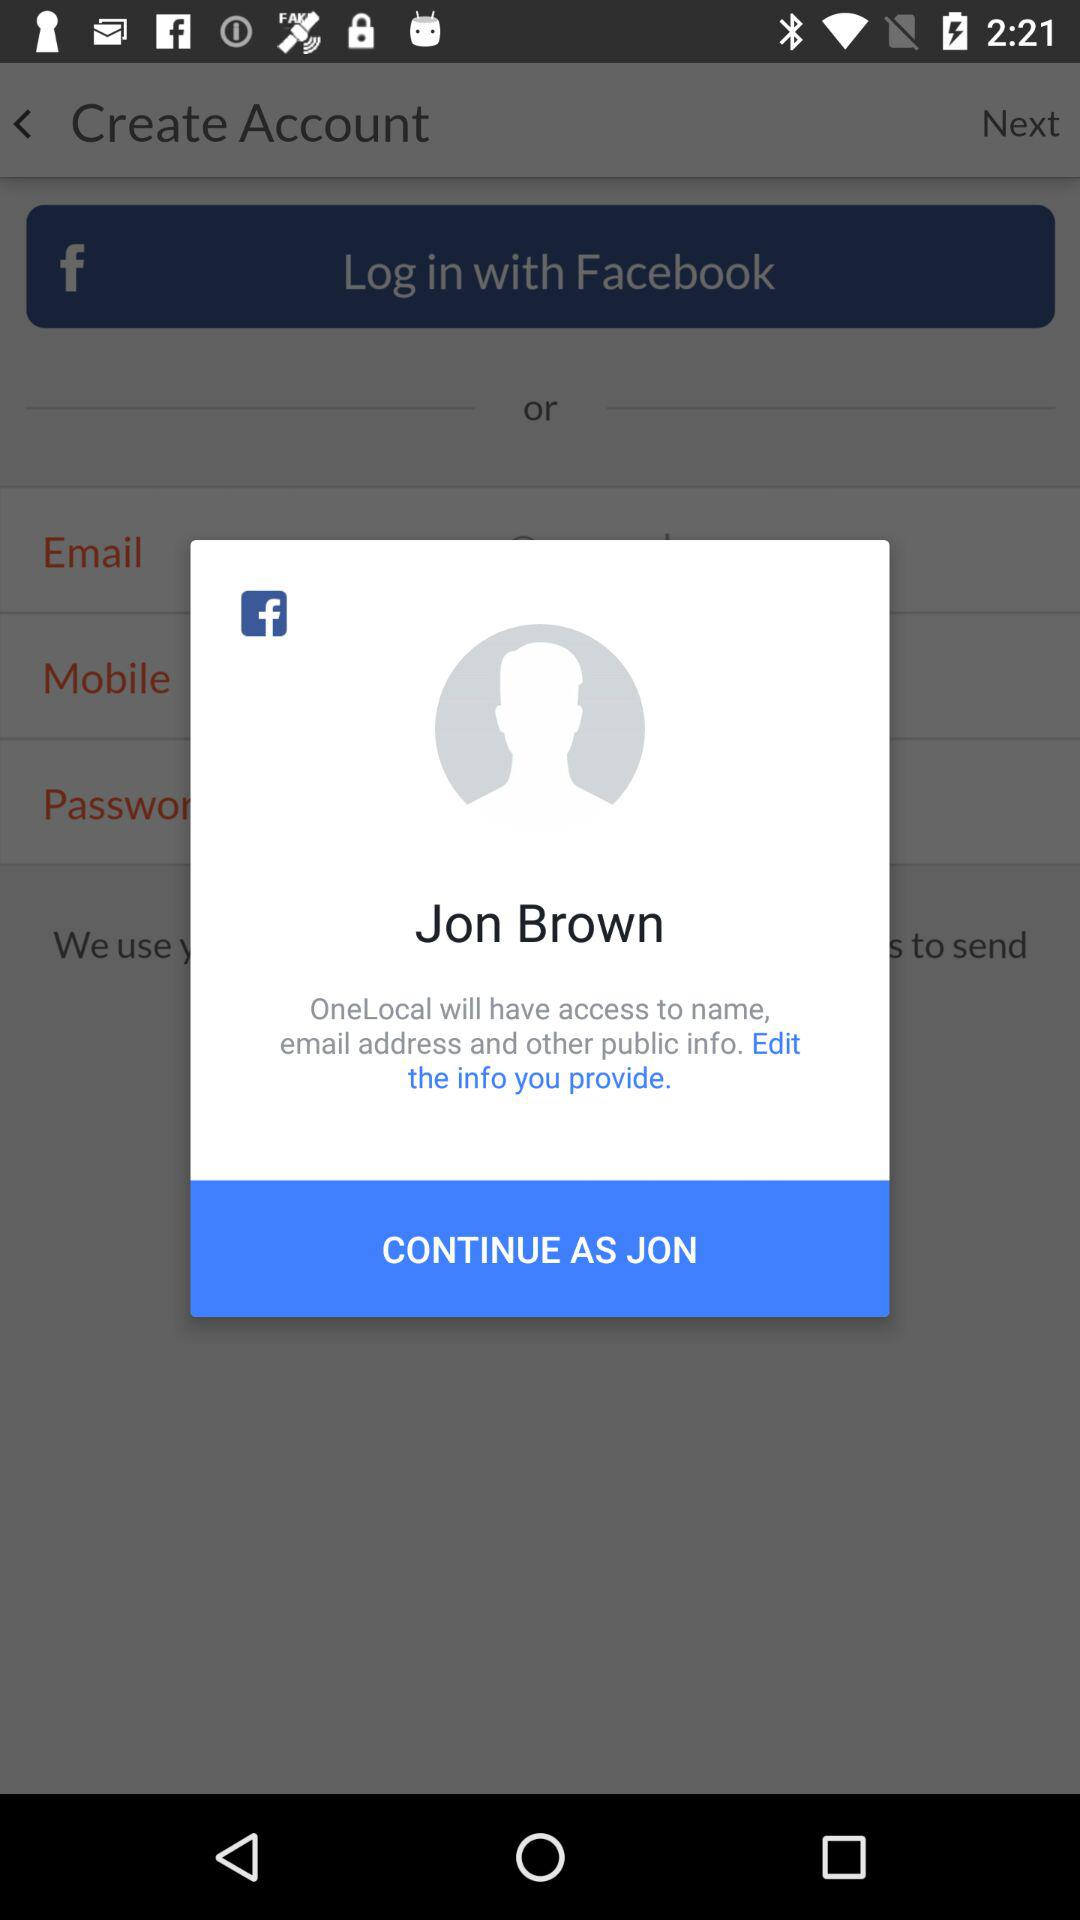What is the login name? The login name is Jon Brown. 